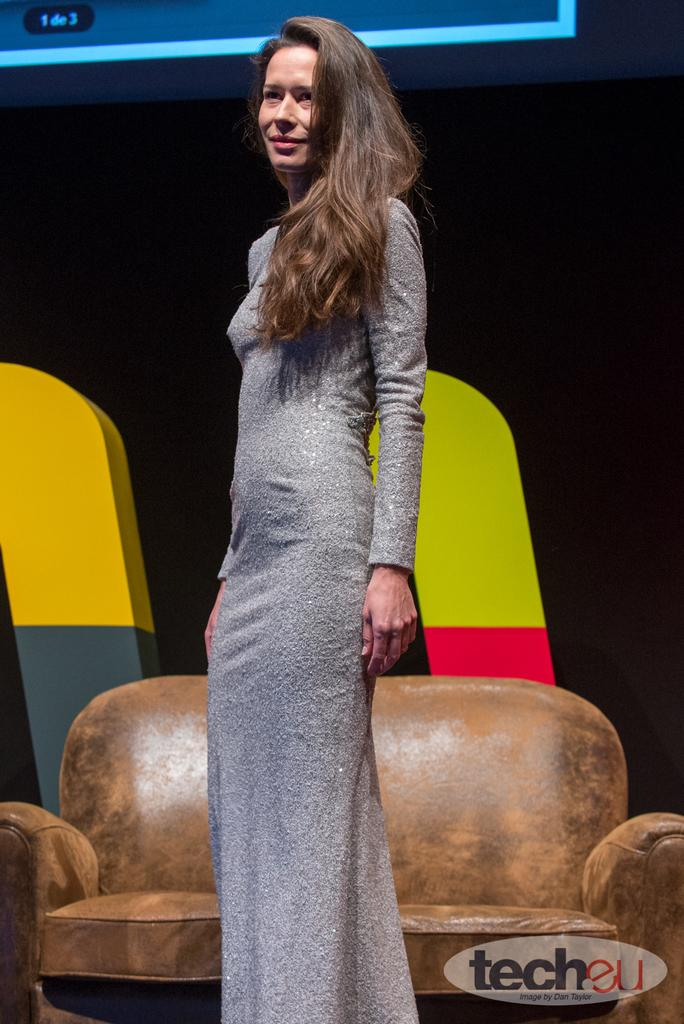Who is the main subject in the image? There is a woman in the image. What is the woman doing in the image? The woman is standing. What is the woman wearing in the image? The woman is wearing an ash-colored dress. What type of furniture is present in the image? There is a brown-colored couch in the image. What route does the cloud take in the image? There is no cloud present in the image, so it is not possible to determine a route. 